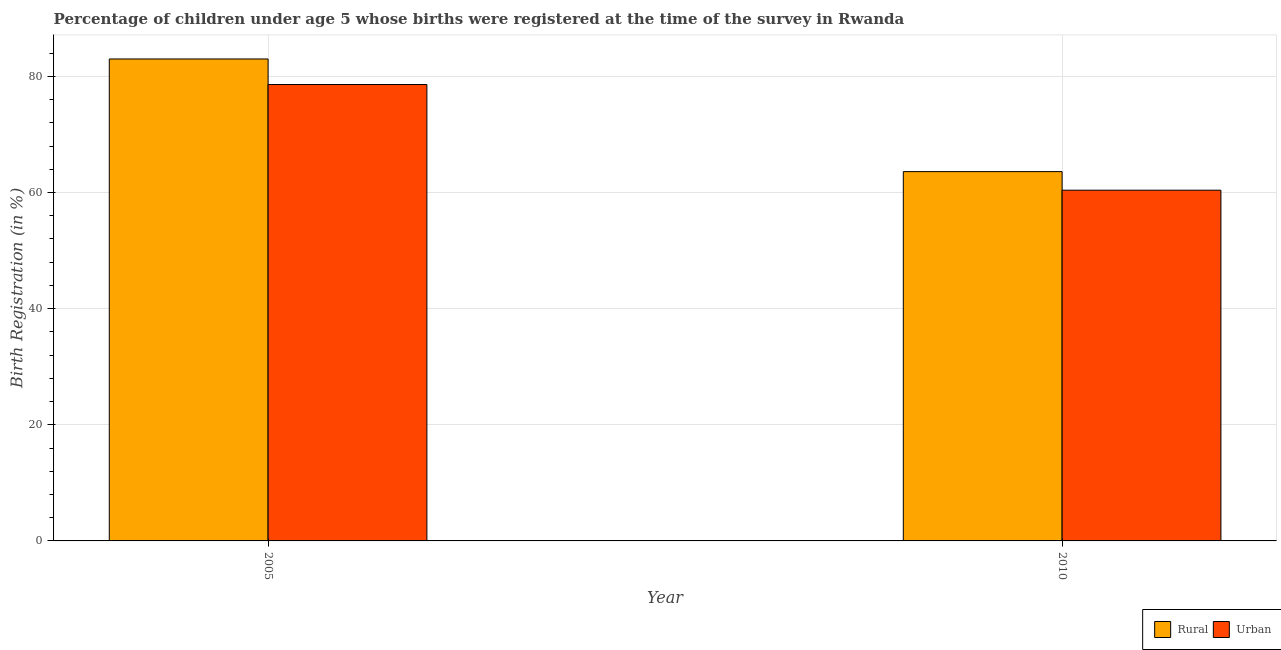Are the number of bars per tick equal to the number of legend labels?
Ensure brevity in your answer.  Yes. Are the number of bars on each tick of the X-axis equal?
Give a very brief answer. Yes. How many bars are there on the 2nd tick from the left?
Your answer should be compact. 2. How many bars are there on the 1st tick from the right?
Your response must be concise. 2. What is the rural birth registration in 2010?
Give a very brief answer. 63.6. Across all years, what is the maximum rural birth registration?
Your answer should be very brief. 83. Across all years, what is the minimum rural birth registration?
Give a very brief answer. 63.6. In which year was the urban birth registration maximum?
Provide a succinct answer. 2005. What is the total urban birth registration in the graph?
Provide a succinct answer. 139. What is the difference between the rural birth registration in 2005 and that in 2010?
Your response must be concise. 19.4. What is the difference between the rural birth registration in 2005 and the urban birth registration in 2010?
Your response must be concise. 19.4. What is the average urban birth registration per year?
Your response must be concise. 69.5. In how many years, is the urban birth registration greater than 12 %?
Keep it short and to the point. 2. What is the ratio of the urban birth registration in 2005 to that in 2010?
Your response must be concise. 1.3. Is the rural birth registration in 2005 less than that in 2010?
Ensure brevity in your answer.  No. What does the 1st bar from the left in 2005 represents?
Give a very brief answer. Rural. What does the 1st bar from the right in 2005 represents?
Give a very brief answer. Urban. How many bars are there?
Ensure brevity in your answer.  4. Are all the bars in the graph horizontal?
Keep it short and to the point. No. How many years are there in the graph?
Make the answer very short. 2. Does the graph contain grids?
Offer a terse response. Yes. Where does the legend appear in the graph?
Provide a short and direct response. Bottom right. How many legend labels are there?
Keep it short and to the point. 2. How are the legend labels stacked?
Make the answer very short. Horizontal. What is the title of the graph?
Offer a terse response. Percentage of children under age 5 whose births were registered at the time of the survey in Rwanda. What is the label or title of the Y-axis?
Offer a terse response. Birth Registration (in %). What is the Birth Registration (in %) in Urban in 2005?
Your answer should be very brief. 78.6. What is the Birth Registration (in %) of Rural in 2010?
Make the answer very short. 63.6. What is the Birth Registration (in %) of Urban in 2010?
Your answer should be very brief. 60.4. Across all years, what is the maximum Birth Registration (in %) in Rural?
Provide a succinct answer. 83. Across all years, what is the maximum Birth Registration (in %) in Urban?
Offer a terse response. 78.6. Across all years, what is the minimum Birth Registration (in %) in Rural?
Give a very brief answer. 63.6. Across all years, what is the minimum Birth Registration (in %) of Urban?
Keep it short and to the point. 60.4. What is the total Birth Registration (in %) of Rural in the graph?
Offer a very short reply. 146.6. What is the total Birth Registration (in %) in Urban in the graph?
Provide a succinct answer. 139. What is the difference between the Birth Registration (in %) of Rural in 2005 and that in 2010?
Make the answer very short. 19.4. What is the difference between the Birth Registration (in %) of Rural in 2005 and the Birth Registration (in %) of Urban in 2010?
Your answer should be very brief. 22.6. What is the average Birth Registration (in %) of Rural per year?
Offer a very short reply. 73.3. What is the average Birth Registration (in %) of Urban per year?
Offer a very short reply. 69.5. In the year 2005, what is the difference between the Birth Registration (in %) of Rural and Birth Registration (in %) of Urban?
Make the answer very short. 4.4. What is the ratio of the Birth Registration (in %) of Rural in 2005 to that in 2010?
Keep it short and to the point. 1.3. What is the ratio of the Birth Registration (in %) of Urban in 2005 to that in 2010?
Your answer should be very brief. 1.3. What is the difference between the highest and the second highest Birth Registration (in %) in Rural?
Make the answer very short. 19.4. What is the difference between the highest and the lowest Birth Registration (in %) of Rural?
Your response must be concise. 19.4. 